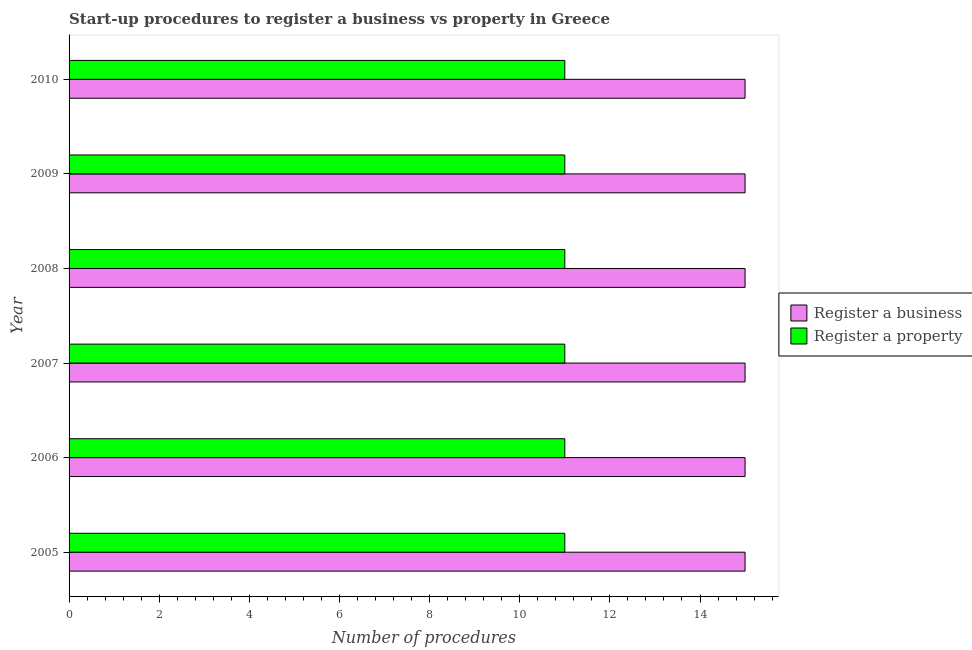How many different coloured bars are there?
Give a very brief answer. 2. Are the number of bars per tick equal to the number of legend labels?
Give a very brief answer. Yes. Are the number of bars on each tick of the Y-axis equal?
Your response must be concise. Yes. How many bars are there on the 6th tick from the top?
Give a very brief answer. 2. How many bars are there on the 1st tick from the bottom?
Make the answer very short. 2. What is the label of the 3rd group of bars from the top?
Make the answer very short. 2008. What is the number of procedures to register a property in 2005?
Keep it short and to the point. 11. Across all years, what is the maximum number of procedures to register a property?
Make the answer very short. 11. Across all years, what is the minimum number of procedures to register a property?
Provide a succinct answer. 11. In which year was the number of procedures to register a business maximum?
Offer a very short reply. 2005. What is the total number of procedures to register a property in the graph?
Your response must be concise. 66. What is the difference between the number of procedures to register a property in 2008 and the number of procedures to register a business in 2007?
Offer a very short reply. -4. What is the average number of procedures to register a property per year?
Make the answer very short. 11. In the year 2008, what is the difference between the number of procedures to register a property and number of procedures to register a business?
Make the answer very short. -4. Is the number of procedures to register a business in 2006 less than that in 2009?
Give a very brief answer. No. Is the difference between the number of procedures to register a business in 2005 and 2009 greater than the difference between the number of procedures to register a property in 2005 and 2009?
Ensure brevity in your answer.  No. What is the difference between the highest and the second highest number of procedures to register a business?
Your answer should be very brief. 0. What is the difference between the highest and the lowest number of procedures to register a property?
Your response must be concise. 0. Is the sum of the number of procedures to register a business in 2005 and 2007 greater than the maximum number of procedures to register a property across all years?
Make the answer very short. Yes. What does the 2nd bar from the top in 2008 represents?
Keep it short and to the point. Register a business. What does the 1st bar from the bottom in 2009 represents?
Provide a succinct answer. Register a business. How many bars are there?
Your answer should be compact. 12. Are all the bars in the graph horizontal?
Your response must be concise. Yes. How many years are there in the graph?
Your answer should be compact. 6. What is the difference between two consecutive major ticks on the X-axis?
Ensure brevity in your answer.  2. Are the values on the major ticks of X-axis written in scientific E-notation?
Your answer should be compact. No. Does the graph contain grids?
Offer a terse response. No. How many legend labels are there?
Your answer should be very brief. 2. How are the legend labels stacked?
Keep it short and to the point. Vertical. What is the title of the graph?
Your answer should be very brief. Start-up procedures to register a business vs property in Greece. What is the label or title of the X-axis?
Offer a very short reply. Number of procedures. What is the Number of procedures in Register a business in 2005?
Offer a terse response. 15. What is the Number of procedures of Register a business in 2006?
Offer a terse response. 15. What is the Number of procedures in Register a property in 2006?
Provide a succinct answer. 11. What is the Number of procedures of Register a property in 2007?
Keep it short and to the point. 11. What is the Number of procedures of Register a business in 2008?
Keep it short and to the point. 15. What is the Number of procedures of Register a property in 2008?
Your response must be concise. 11. What is the Number of procedures in Register a business in 2009?
Your response must be concise. 15. What is the Number of procedures in Register a business in 2010?
Your response must be concise. 15. Across all years, what is the maximum Number of procedures of Register a business?
Make the answer very short. 15. Across all years, what is the maximum Number of procedures in Register a property?
Your response must be concise. 11. Across all years, what is the minimum Number of procedures of Register a property?
Your response must be concise. 11. What is the total Number of procedures of Register a business in the graph?
Your answer should be compact. 90. What is the difference between the Number of procedures in Register a business in 2005 and that in 2006?
Your answer should be very brief. 0. What is the difference between the Number of procedures in Register a property in 2005 and that in 2006?
Ensure brevity in your answer.  0. What is the difference between the Number of procedures in Register a business in 2005 and that in 2008?
Offer a very short reply. 0. What is the difference between the Number of procedures of Register a property in 2005 and that in 2008?
Offer a very short reply. 0. What is the difference between the Number of procedures of Register a business in 2005 and that in 2009?
Offer a very short reply. 0. What is the difference between the Number of procedures in Register a business in 2005 and that in 2010?
Make the answer very short. 0. What is the difference between the Number of procedures in Register a property in 2005 and that in 2010?
Your answer should be compact. 0. What is the difference between the Number of procedures in Register a property in 2006 and that in 2007?
Provide a succinct answer. 0. What is the difference between the Number of procedures in Register a business in 2006 and that in 2008?
Provide a succinct answer. 0. What is the difference between the Number of procedures in Register a property in 2006 and that in 2008?
Offer a very short reply. 0. What is the difference between the Number of procedures in Register a property in 2006 and that in 2010?
Give a very brief answer. 0. What is the difference between the Number of procedures of Register a property in 2007 and that in 2008?
Your response must be concise. 0. What is the difference between the Number of procedures of Register a business in 2007 and that in 2009?
Provide a short and direct response. 0. What is the difference between the Number of procedures of Register a property in 2007 and that in 2009?
Offer a very short reply. 0. What is the difference between the Number of procedures in Register a business in 2007 and that in 2010?
Offer a terse response. 0. What is the difference between the Number of procedures of Register a property in 2008 and that in 2009?
Keep it short and to the point. 0. What is the difference between the Number of procedures of Register a business in 2005 and the Number of procedures of Register a property in 2006?
Your response must be concise. 4. What is the difference between the Number of procedures of Register a business in 2006 and the Number of procedures of Register a property in 2007?
Your answer should be very brief. 4. What is the difference between the Number of procedures in Register a business in 2006 and the Number of procedures in Register a property in 2008?
Provide a short and direct response. 4. What is the difference between the Number of procedures in Register a business in 2006 and the Number of procedures in Register a property in 2009?
Provide a short and direct response. 4. What is the difference between the Number of procedures in Register a business in 2008 and the Number of procedures in Register a property in 2010?
Provide a succinct answer. 4. What is the difference between the Number of procedures of Register a business in 2009 and the Number of procedures of Register a property in 2010?
Provide a short and direct response. 4. What is the average Number of procedures of Register a property per year?
Your answer should be compact. 11. In the year 2005, what is the difference between the Number of procedures of Register a business and Number of procedures of Register a property?
Offer a terse response. 4. In the year 2007, what is the difference between the Number of procedures in Register a business and Number of procedures in Register a property?
Ensure brevity in your answer.  4. In the year 2008, what is the difference between the Number of procedures in Register a business and Number of procedures in Register a property?
Give a very brief answer. 4. In the year 2009, what is the difference between the Number of procedures of Register a business and Number of procedures of Register a property?
Offer a terse response. 4. What is the ratio of the Number of procedures of Register a business in 2005 to that in 2006?
Offer a terse response. 1. What is the ratio of the Number of procedures in Register a business in 2005 to that in 2007?
Provide a succinct answer. 1. What is the ratio of the Number of procedures of Register a property in 2005 to that in 2007?
Your answer should be compact. 1. What is the ratio of the Number of procedures in Register a property in 2005 to that in 2008?
Make the answer very short. 1. What is the ratio of the Number of procedures in Register a business in 2006 to that in 2007?
Ensure brevity in your answer.  1. What is the ratio of the Number of procedures of Register a business in 2006 to that in 2008?
Ensure brevity in your answer.  1. What is the ratio of the Number of procedures of Register a property in 2006 to that in 2008?
Your answer should be compact. 1. What is the ratio of the Number of procedures in Register a property in 2006 to that in 2009?
Offer a terse response. 1. What is the ratio of the Number of procedures of Register a business in 2007 to that in 2008?
Your answer should be very brief. 1. What is the ratio of the Number of procedures of Register a property in 2007 to that in 2008?
Offer a very short reply. 1. What is the ratio of the Number of procedures of Register a business in 2007 to that in 2009?
Offer a terse response. 1. What is the ratio of the Number of procedures in Register a business in 2007 to that in 2010?
Offer a very short reply. 1. What is the ratio of the Number of procedures in Register a business in 2008 to that in 2010?
Make the answer very short. 1. What is the ratio of the Number of procedures of Register a business in 2009 to that in 2010?
Provide a short and direct response. 1. What is the difference between the highest and the lowest Number of procedures of Register a business?
Your answer should be compact. 0. 